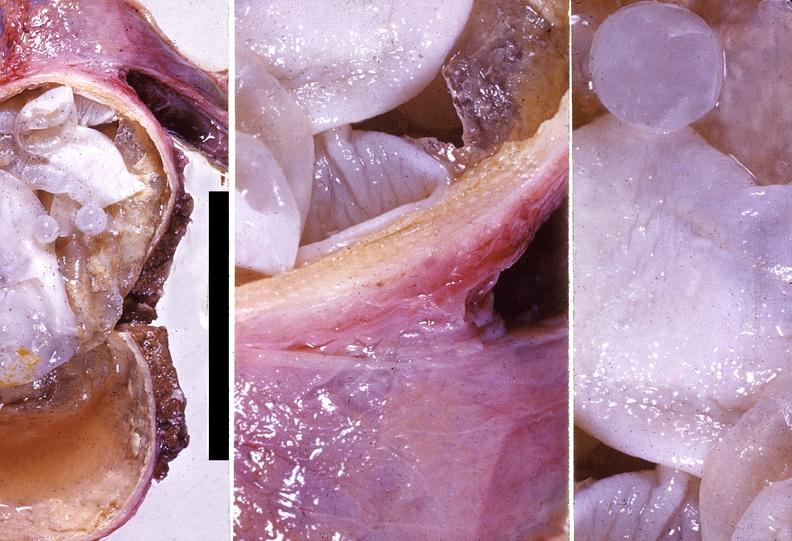does lymphoblastic lymphoma show liver, echinococcal cysts echinococcus, hydatidosis ; hydatid disease, hydatid cyst disease?
Answer the question using a single word or phrase. No 